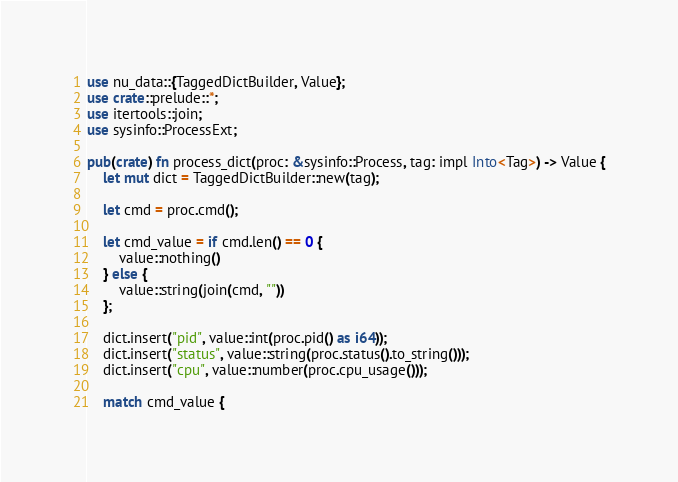<code> <loc_0><loc_0><loc_500><loc_500><_Rust_>use nu_data::{TaggedDictBuilder, Value};
use crate::prelude::*;
use itertools::join;
use sysinfo::ProcessExt;

pub(crate) fn process_dict(proc: &sysinfo::Process, tag: impl Into<Tag>) -> Value {
    let mut dict = TaggedDictBuilder::new(tag);

    let cmd = proc.cmd();

    let cmd_value = if cmd.len() == 0 {
        value::nothing()
    } else {
        value::string(join(cmd, ""))
    };

    dict.insert("pid", value::int(proc.pid() as i64));
    dict.insert("status", value::string(proc.status().to_string()));
    dict.insert("cpu", value::number(proc.cpu_usage()));

    match cmd_value {</code> 